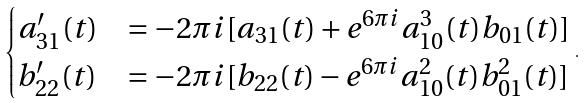<formula> <loc_0><loc_0><loc_500><loc_500>\begin{cases} a _ { 3 1 } ^ { \prime } ( t ) & = - 2 \pi i [ a _ { 3 1 } ( t ) + e ^ { 6 \pi i } a _ { 1 0 } ^ { 3 } ( t ) b _ { 0 1 } ( t ) ] \\ b _ { 2 2 } ^ { \prime } ( t ) & = - 2 \pi i [ b _ { 2 2 } ( t ) - e ^ { 6 \pi i } a _ { 1 0 } ^ { 2 } ( t ) b _ { 0 1 } ^ { 2 } ( t ) ] \end{cases} \, .</formula> 